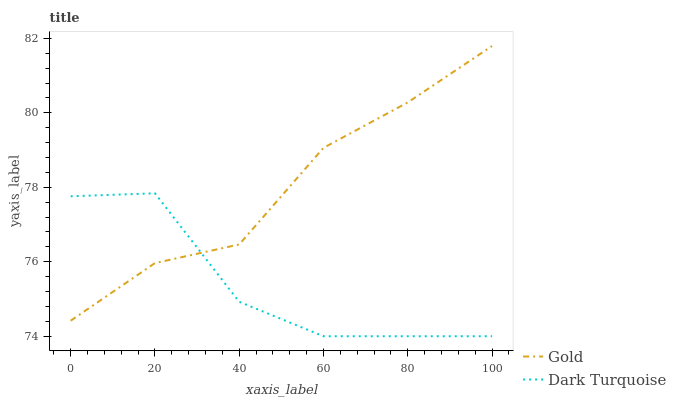Does Dark Turquoise have the minimum area under the curve?
Answer yes or no. Yes. Does Gold have the maximum area under the curve?
Answer yes or no. Yes. Does Gold have the minimum area under the curve?
Answer yes or no. No. Is Gold the smoothest?
Answer yes or no. Yes. Is Dark Turquoise the roughest?
Answer yes or no. Yes. Is Gold the roughest?
Answer yes or no. No. Does Dark Turquoise have the lowest value?
Answer yes or no. Yes. Does Gold have the lowest value?
Answer yes or no. No. Does Gold have the highest value?
Answer yes or no. Yes. Does Dark Turquoise intersect Gold?
Answer yes or no. Yes. Is Dark Turquoise less than Gold?
Answer yes or no. No. Is Dark Turquoise greater than Gold?
Answer yes or no. No. 